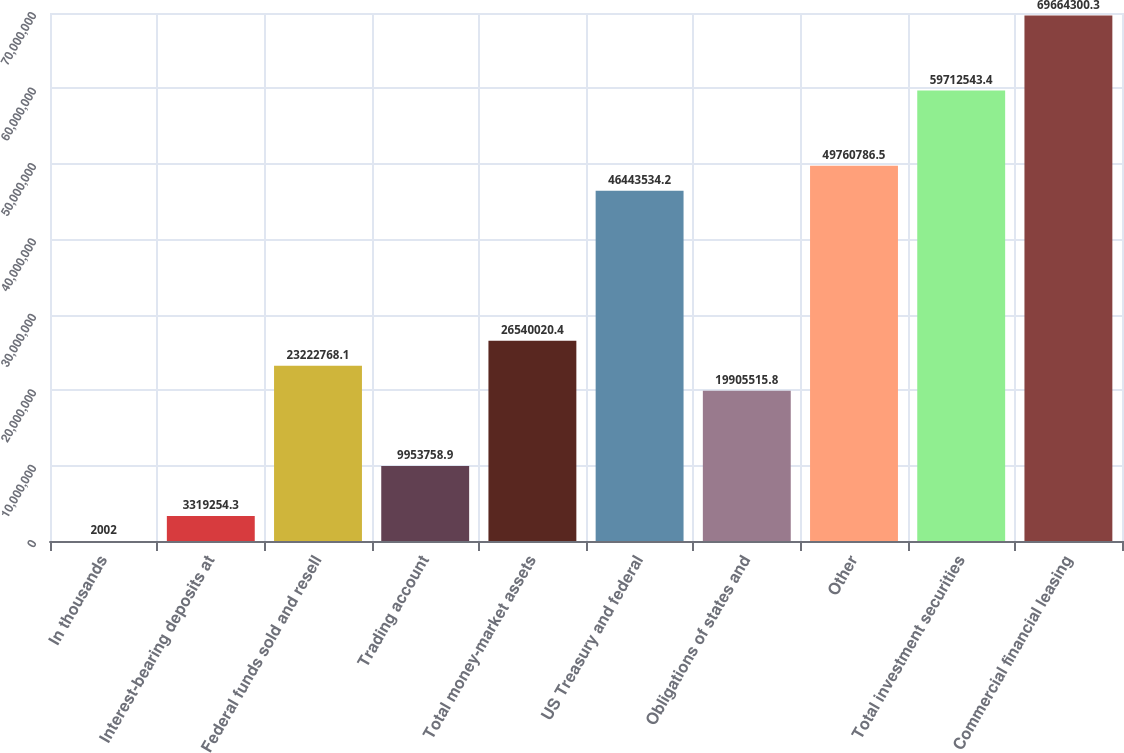Convert chart to OTSL. <chart><loc_0><loc_0><loc_500><loc_500><bar_chart><fcel>In thousands<fcel>Interest-bearing deposits at<fcel>Federal funds sold and resell<fcel>Trading account<fcel>Total money-market assets<fcel>US Treasury and federal<fcel>Obligations of states and<fcel>Other<fcel>Total investment securities<fcel>Commercial financial leasing<nl><fcel>2002<fcel>3.31925e+06<fcel>2.32228e+07<fcel>9.95376e+06<fcel>2.654e+07<fcel>4.64435e+07<fcel>1.99055e+07<fcel>4.97608e+07<fcel>5.97125e+07<fcel>6.96643e+07<nl></chart> 